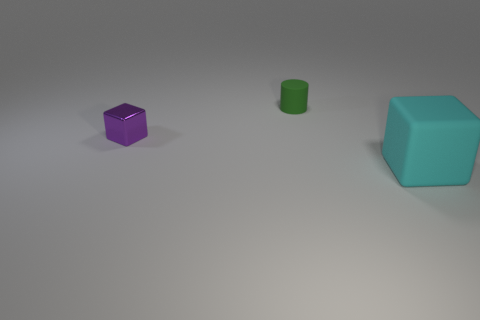What number of things are either objects that are on the right side of the rubber cylinder or large cyan matte things?
Keep it short and to the point. 1. Do the small cylinder and the block that is on the left side of the matte block have the same color?
Keep it short and to the point. No. Are there any other things that are the same size as the cylinder?
Your answer should be very brief. Yes. How big is the cube on the left side of the block that is in front of the purple object?
Make the answer very short. Small. What number of things are big red metallic balls or things on the right side of the metal thing?
Ensure brevity in your answer.  2. There is a thing that is left of the tiny green thing; is its shape the same as the small rubber thing?
Give a very brief answer. No. There is a small thing that is in front of the matte object that is left of the large block; what number of matte things are behind it?
Offer a very short reply. 1. Are there any other things that have the same shape as the purple thing?
Your response must be concise. Yes. What number of things are either red rubber balls or cyan objects?
Make the answer very short. 1. There is a purple object; is it the same shape as the matte thing that is on the left side of the large thing?
Keep it short and to the point. No. 